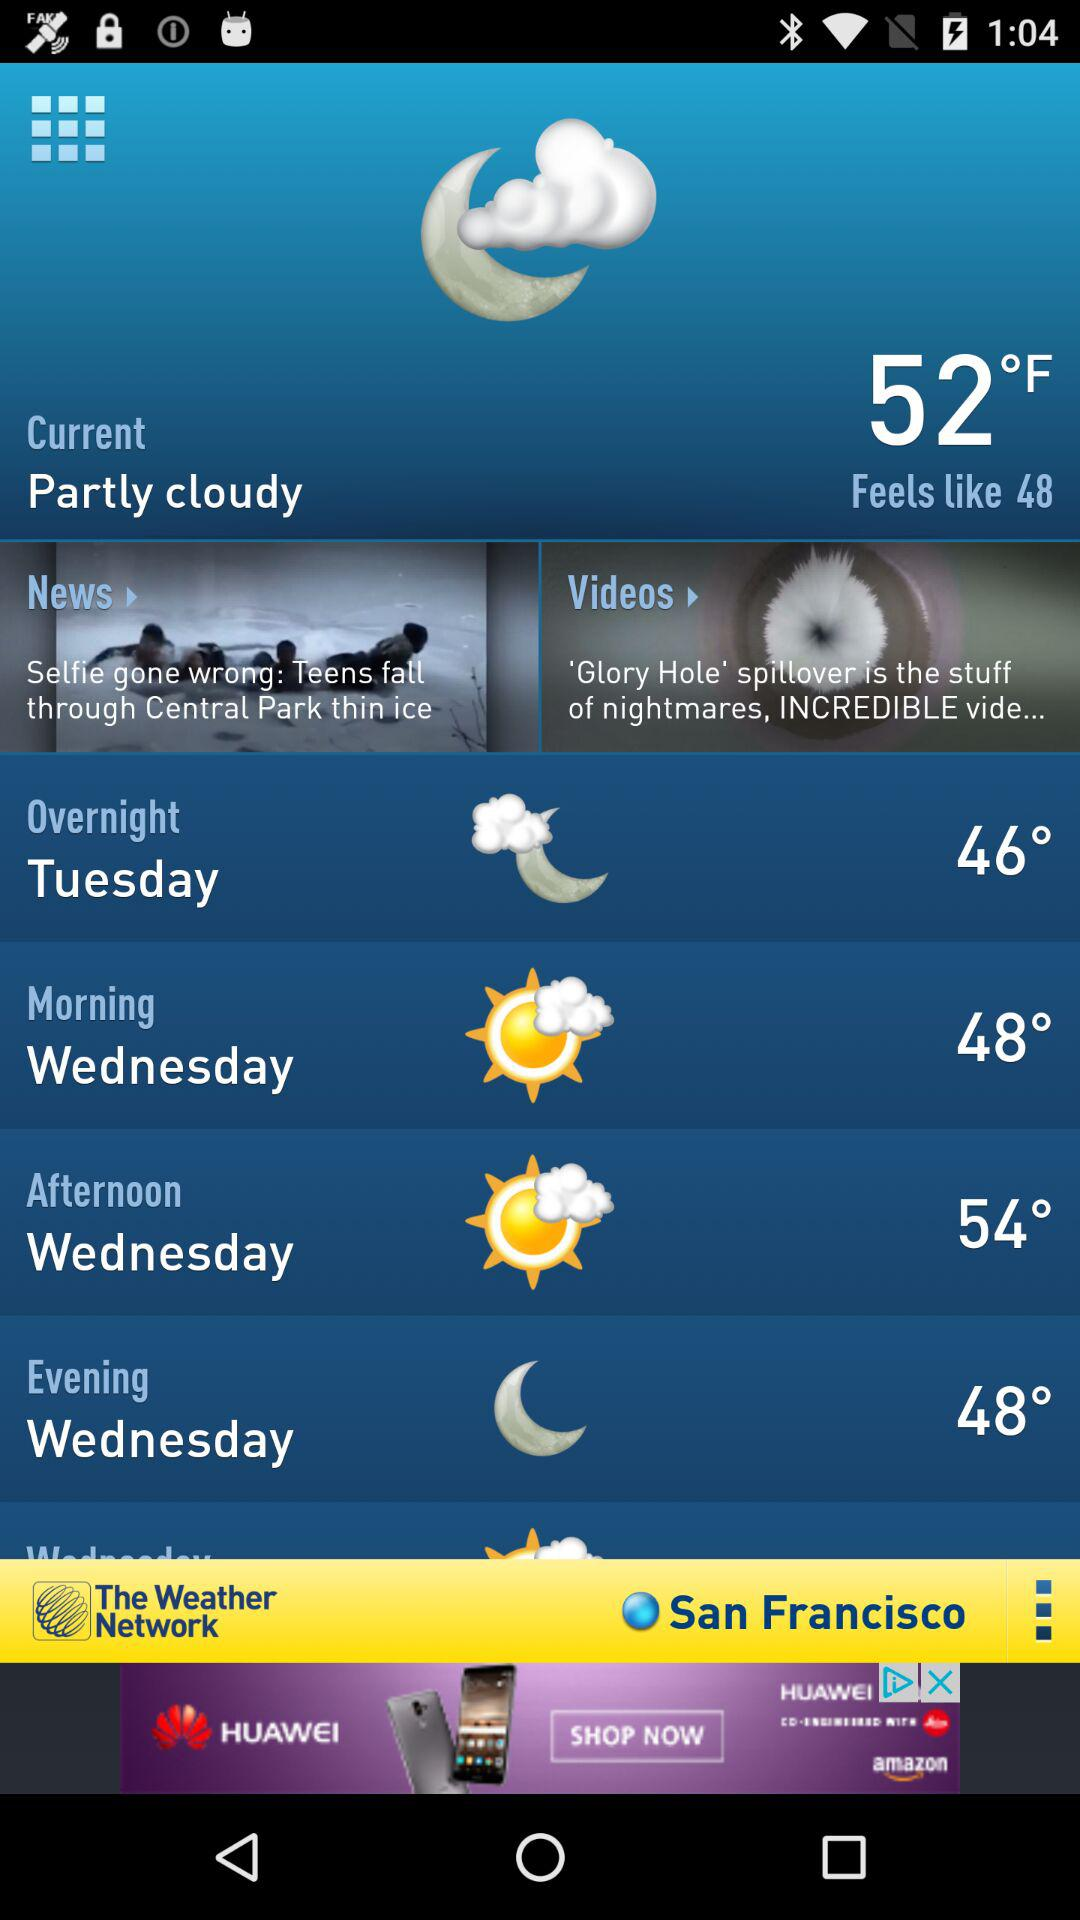What is the weather forecast for Wednesday evening? The weather forecast says that the temperature is 48°. 